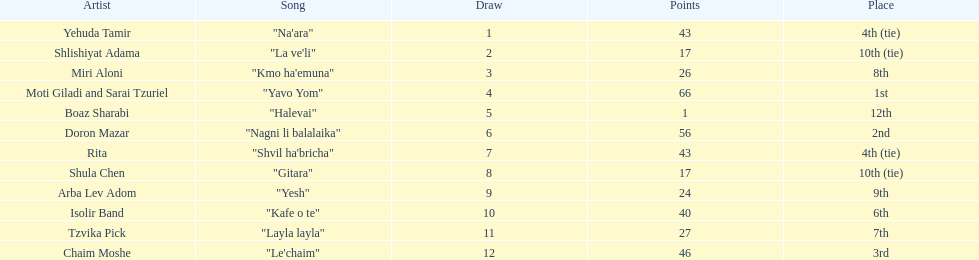What is the name of the first song listed on this chart? "Na'ara". 